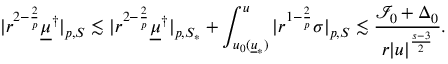<formula> <loc_0><loc_0><loc_500><loc_500>| r ^ { 2 - \frac { 2 } { p } } { \underline { \mu } } ^ { \dagger } | _ { p , S } \lesssim | r ^ { 2 - \frac { 2 } { p } } { \underline { \mu } } ^ { \dagger } | _ { p , S _ { * } } + \int _ { u _ { 0 } ( { \underline { u } } _ { * } ) } ^ { u } | r ^ { 1 - \frac { 2 } { p } } \sigma | _ { p , S } \lesssim \frac { \mathcal { I } _ { 0 } + \Delta _ { 0 } } { r | u | ^ { \frac { s - 3 } { 2 } } } .</formula> 